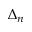<formula> <loc_0><loc_0><loc_500><loc_500>\Delta _ { n }</formula> 